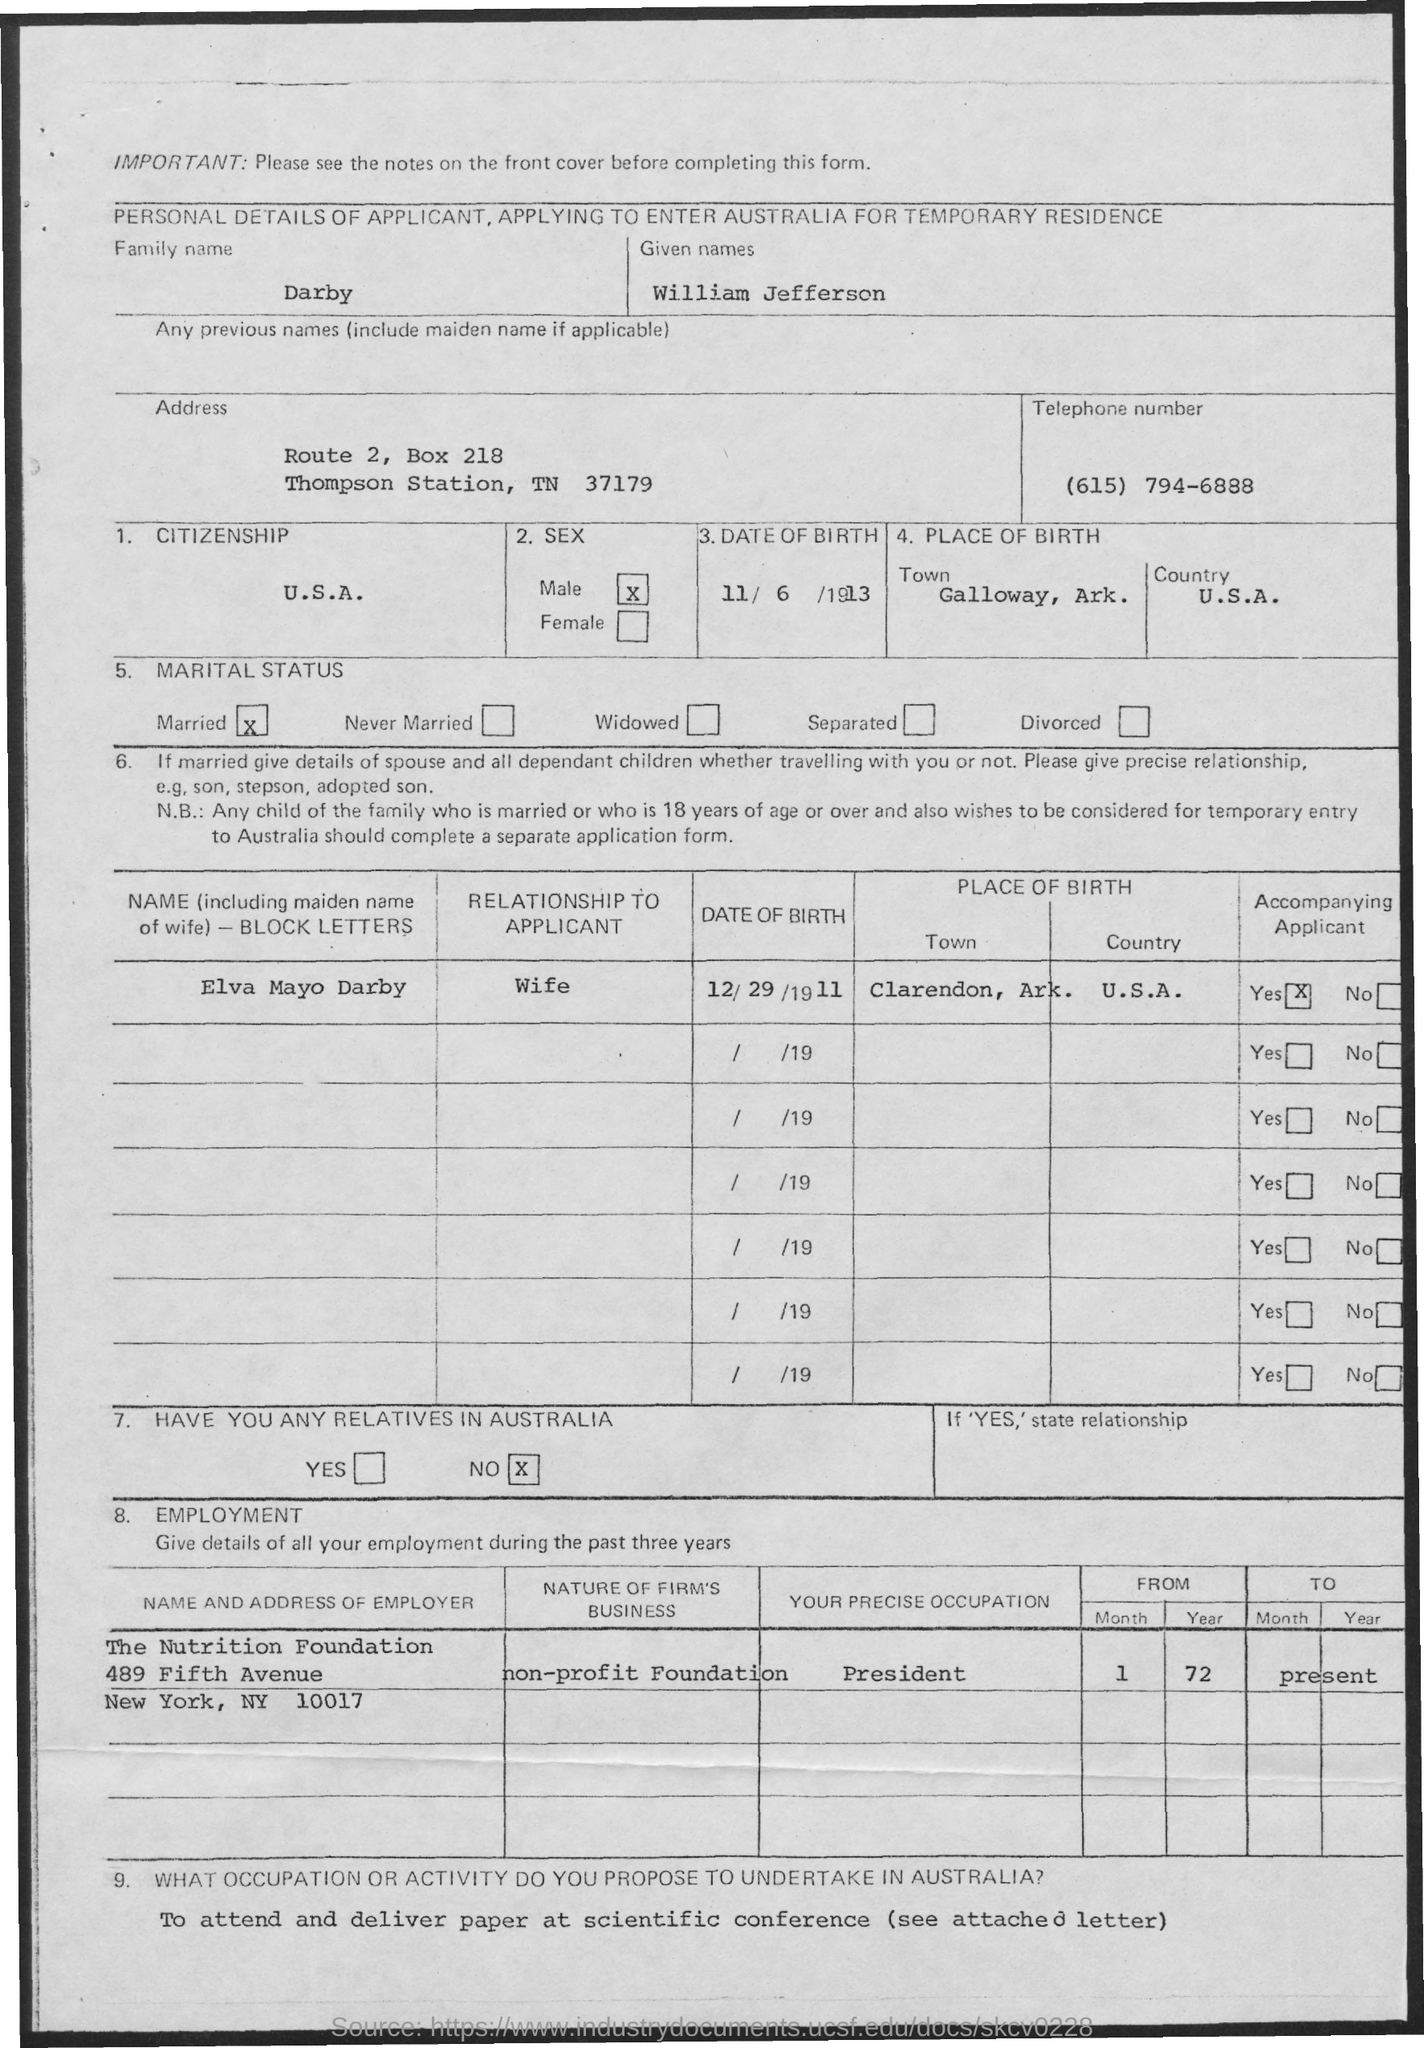What is the Family name of the applicant?
Ensure brevity in your answer.  Darby. What is the Telephone No mentioned in the application?
Provide a succinct answer. (615) 794-6888. What is the date of birth of William Jefferson Darby?
Ensure brevity in your answer.  11/6/1913. Which is the Birthplace of William Jefferson Darby?
Your response must be concise. Galloway, Ark. What is the Citizenship of William Jefferson Darby?
Offer a terse response. U.S.A. Who is William Jefferson Darby's wife?
Offer a very short reply. Elva Mayo Darby. What is the Date of Birth of Elva Mayo Darby?
Provide a short and direct response. 12/29/1911. 